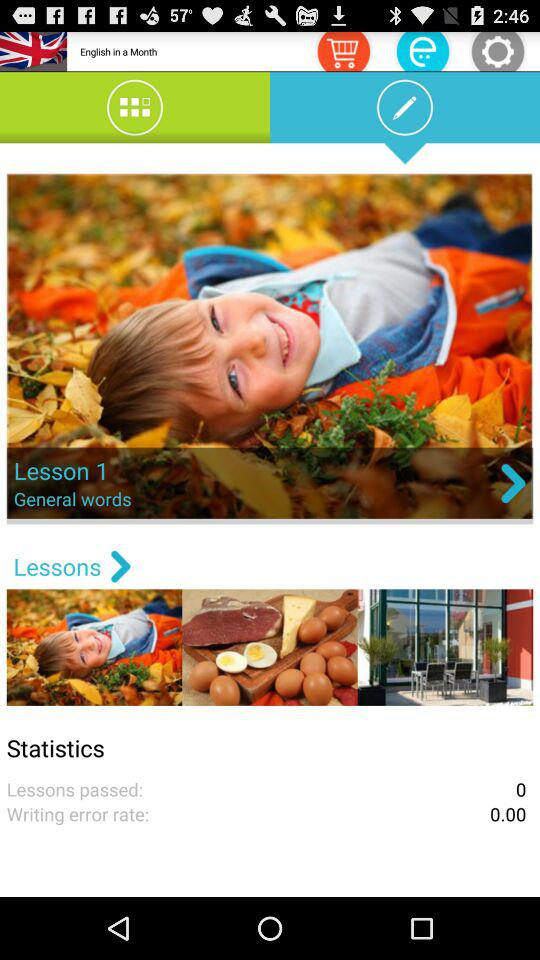How many lessons have been passed? There have been 0 lessons passed. 